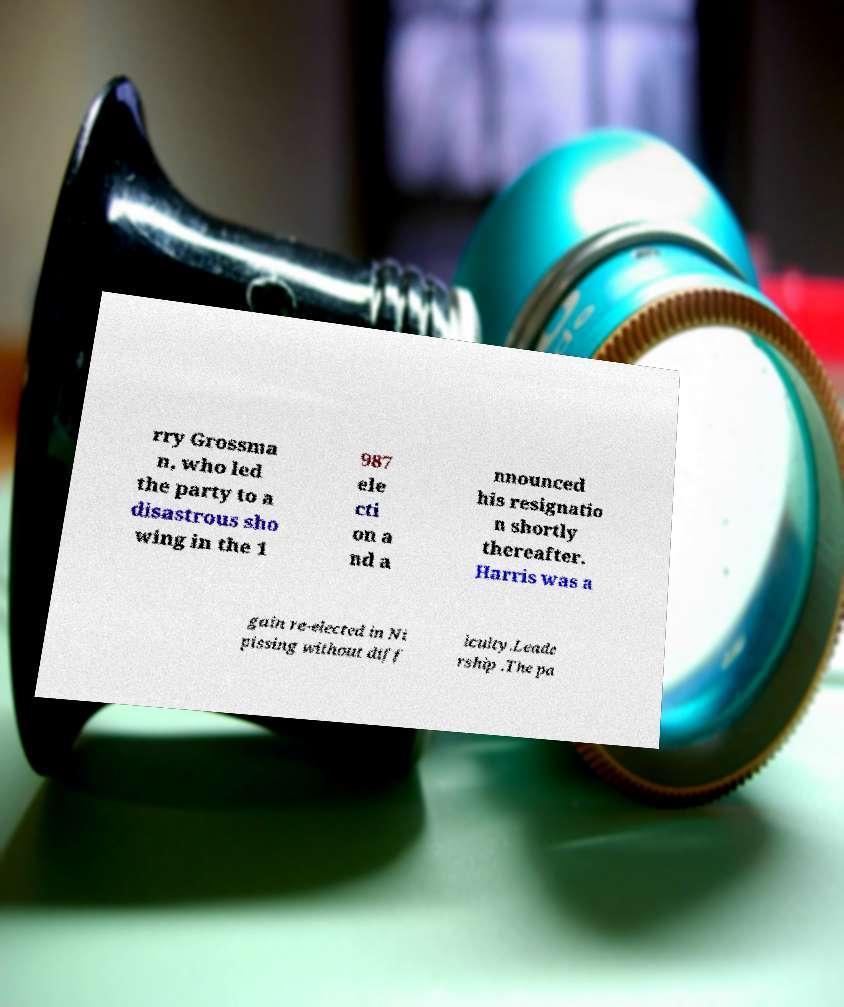Could you assist in decoding the text presented in this image and type it out clearly? rry Grossma n, who led the party to a disastrous sho wing in the 1 987 ele cti on a nd a nnounced his resignatio n shortly thereafter. Harris was a gain re-elected in Ni pissing without diff iculty.Leade rship .The pa 